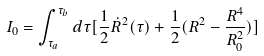<formula> <loc_0><loc_0><loc_500><loc_500>I _ { 0 } = \int _ { \tau _ { a } } ^ { \tau _ { b } } d \tau [ \frac { 1 } { 2 } \dot { R } ^ { 2 } ( \tau ) + \frac { 1 } { 2 } ( R ^ { 2 } - \frac { R ^ { 4 } } { R _ { 0 } ^ { 2 } } ) ]</formula> 